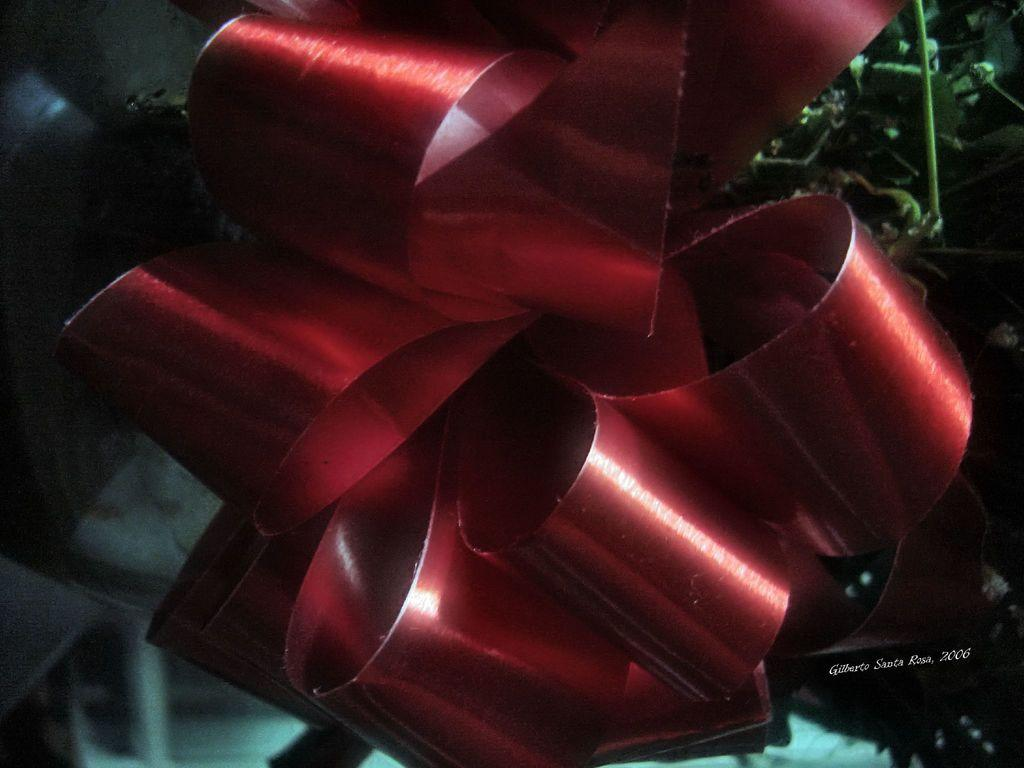What type of decorative item can be seen in the image? There is a decorating binding ribbon in the image. How might this ribbon be used? The ribbon could be used for binding, decorating, or tying objects together. What is the trick that the ribbon performs in the image? There is no trick being performed by the ribbon in the image; it is simply a decorative item. 